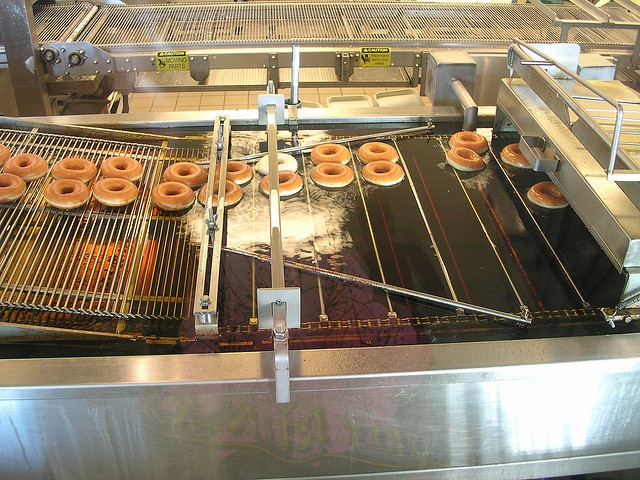Describe the objects in this image and their specific colors. I can see donut in gray, orange, brown, tan, and beige tones, donut in gray, tan, orange, and red tones, donut in gray, orange, and red tones, donut in gray, orange, and brown tones, and donut in gray, orange, brown, khaki, and maroon tones in this image. 